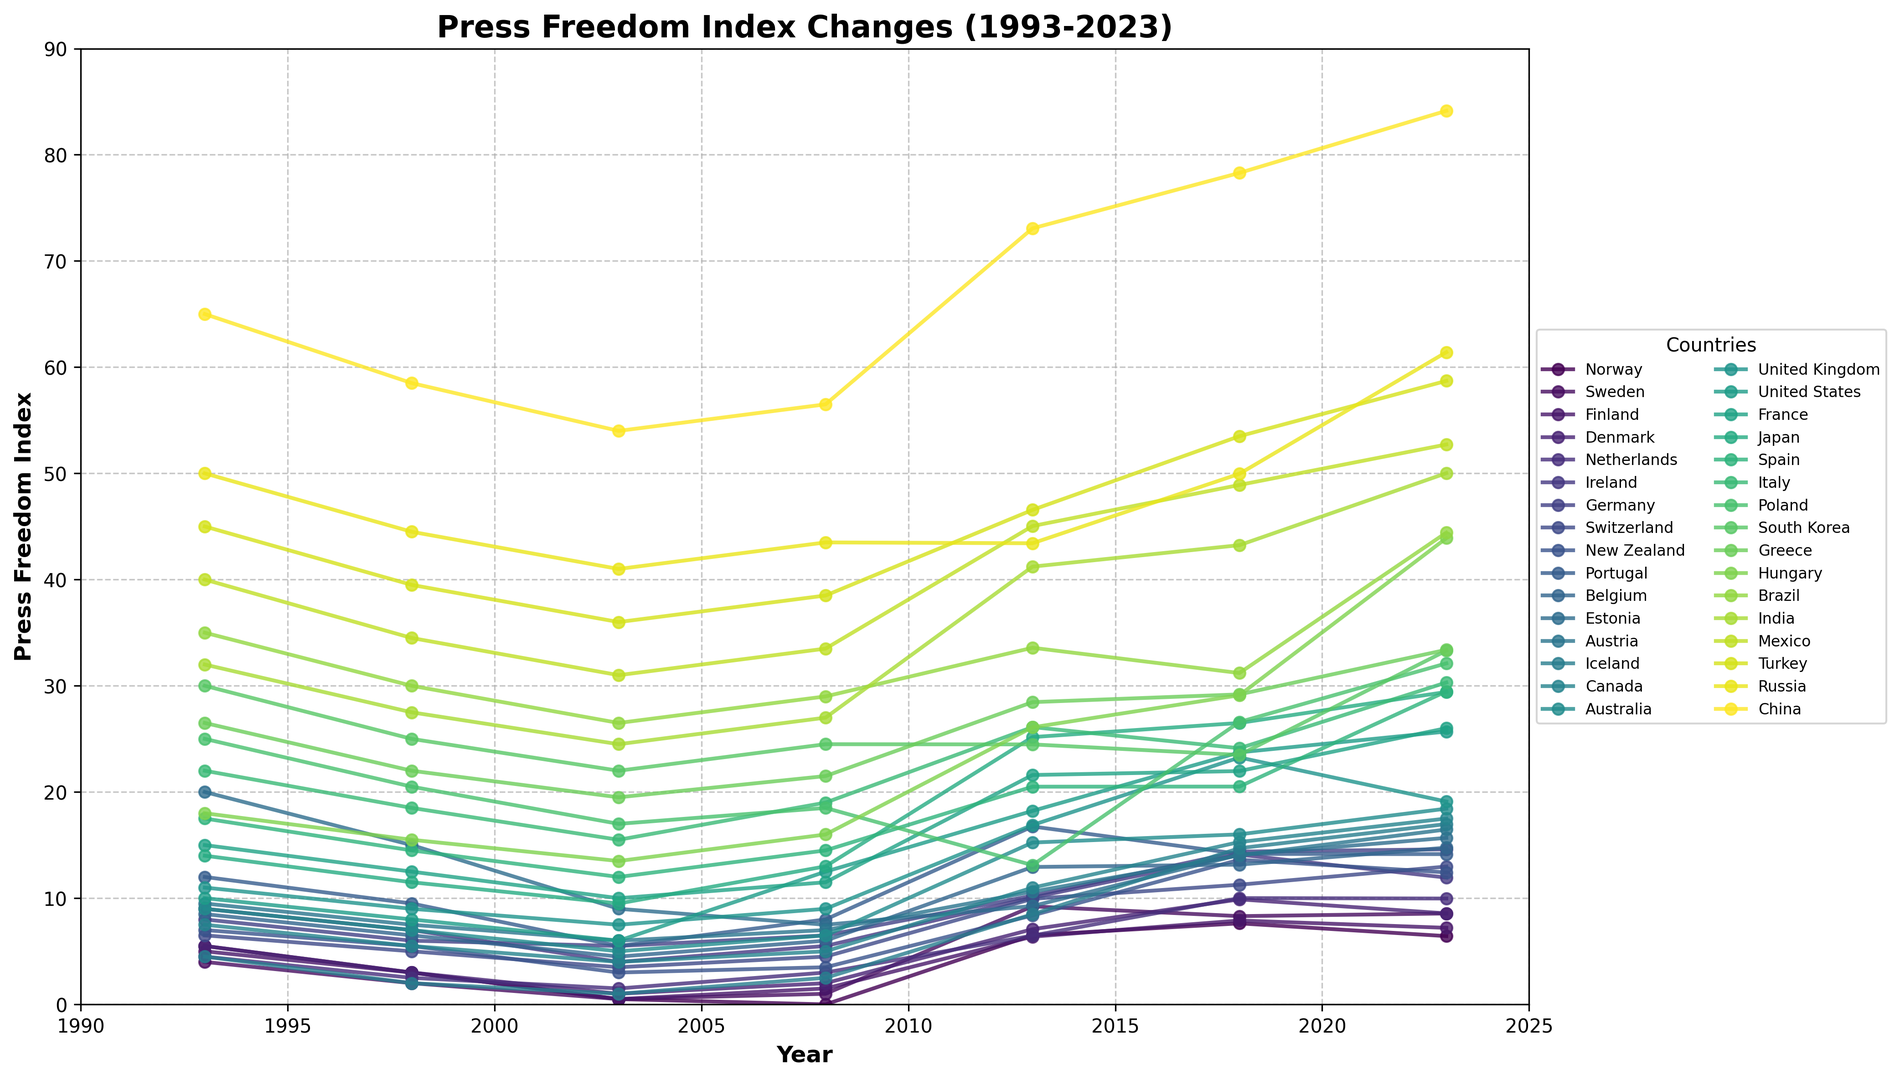Which country had the lowest Press Freedom Index in 2023? To determine the country with the lowest Press Freedom Index in 2023, look for the data series that has the lowest value at the point corresponding to the year 2023. In this case, refer to the values plotted for 2023 and find the smallest point. The country with the lowest value is Norway.
Answer: Norway Which country showed the most significant increase in its Press Freedom Index from 1993 to 2023? To find the country with the most significant increase in Press Freedom Index from 1993 to 2023, calculate the difference between the indices of each country between these years. The most significant increase is seen by tracking the largest change in value. By examining the plotted values, China exhibits the most significant increase from 1993 (65.0) to 2023 (84.14).
Answer: China What is the average Press Freedom Index of the top three countries with the lowest index in 2023? Identify the three countries with the lowest Press Freedom Index values in 2023, which are Norway, Sweden, and Finland. Then, calculate the average by summing their values and dividing by three: (6.43 + 8.56 + 7.21) / 3 = 7.4.
Answer: 7.4 Which country has consistently shown an improvement in its Press Freedom Index from 1993 to 2023? To find a country that has consistently improved, inspect the trend lines and look for a steadily decreasing line across all years. Norway shows a consistent improvement, with values starting at 5.5 in 1993 and dropping gradually to 6.43 in 2023.
Answer: Norway Among the countries listed, which one had the highest Press Freedom Index in 2013 and how does it compare with its Index in 2023? Look at the values for each country in 2013 and find the highest one. The highest value in 2013 is for India at 41.22. Then, compare this with India's value in 2023, which is 50.02, showing an increase.
Answer: India's Index in 2013 was 41.22; it increased to 50.02 in 2023 What is the difference between the Press Freedom Index of the United States and China in 2023? Subtract China’s Press Freedom Index in 2023 from the United States' Press Freedom Index in 2023: 25.69 - 84.14 = -58.45.
Answer: -58.45 Which country had a sharp rise in the Press Freedom Index between 2008 and 2013, and by how much? Compare the difference in values between 2008 and 2013 for each country. India had a sharp increase from 27.0 in 2008 to 41.22 in 2013, an increase by 14.22.
Answer: India increased by 14.22 How does Finland’s Press Freedom Index in 1993 compare to its Index in 2023? Examine Finland’s values in 1993 and 2023. Finland's Index in 1993 was 5.0, and in 2023 it is 7.21. Thus, Finland experienced a minor increase.
Answer: An increase from 5.0 to 7.21 